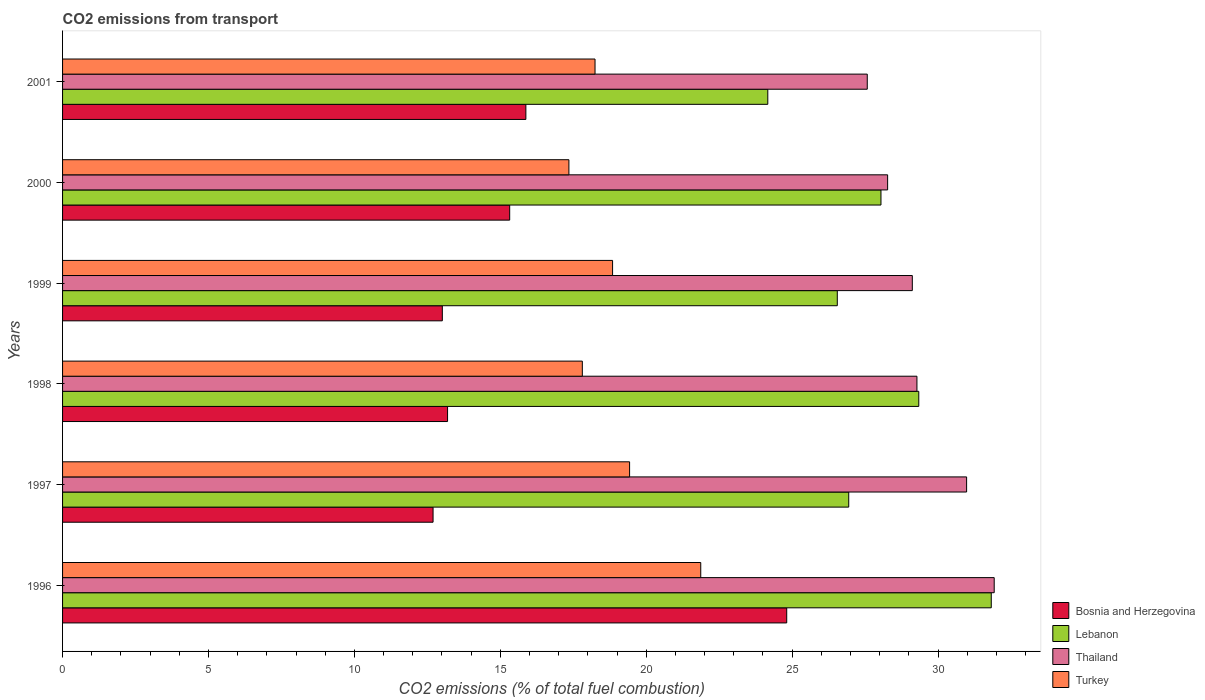How many groups of bars are there?
Keep it short and to the point. 6. Are the number of bars per tick equal to the number of legend labels?
Offer a very short reply. Yes. How many bars are there on the 4th tick from the top?
Ensure brevity in your answer.  4. How many bars are there on the 4th tick from the bottom?
Ensure brevity in your answer.  4. What is the label of the 2nd group of bars from the top?
Your response must be concise. 2000. In how many cases, is the number of bars for a given year not equal to the number of legend labels?
Provide a succinct answer. 0. What is the total CO2 emitted in Thailand in 1997?
Your answer should be very brief. 30.98. Across all years, what is the maximum total CO2 emitted in Lebanon?
Offer a very short reply. 31.82. Across all years, what is the minimum total CO2 emitted in Lebanon?
Your answer should be very brief. 24.17. What is the total total CO2 emitted in Lebanon in the graph?
Offer a very short reply. 166.87. What is the difference between the total CO2 emitted in Bosnia and Herzegovina in 1997 and that in 2000?
Your response must be concise. -2.63. What is the difference between the total CO2 emitted in Thailand in 2000 and the total CO2 emitted in Turkey in 1997?
Give a very brief answer. 8.84. What is the average total CO2 emitted in Turkey per year?
Provide a succinct answer. 18.93. In the year 2001, what is the difference between the total CO2 emitted in Turkey and total CO2 emitted in Bosnia and Herzegovina?
Provide a short and direct response. 2.37. What is the ratio of the total CO2 emitted in Bosnia and Herzegovina in 1996 to that in 1997?
Give a very brief answer. 1.95. Is the total CO2 emitted in Lebanon in 1997 less than that in 1999?
Your answer should be very brief. No. What is the difference between the highest and the second highest total CO2 emitted in Bosnia and Herzegovina?
Offer a terse response. 8.94. What is the difference between the highest and the lowest total CO2 emitted in Turkey?
Make the answer very short. 4.52. What does the 3rd bar from the top in 1998 represents?
Your answer should be very brief. Lebanon. What does the 4th bar from the bottom in 2001 represents?
Your response must be concise. Turkey. Is it the case that in every year, the sum of the total CO2 emitted in Thailand and total CO2 emitted in Turkey is greater than the total CO2 emitted in Lebanon?
Provide a succinct answer. Yes. How many bars are there?
Give a very brief answer. 24. How many years are there in the graph?
Ensure brevity in your answer.  6. Are the values on the major ticks of X-axis written in scientific E-notation?
Ensure brevity in your answer.  No. Does the graph contain any zero values?
Make the answer very short. No. Does the graph contain grids?
Your answer should be very brief. No. Where does the legend appear in the graph?
Offer a very short reply. Bottom right. How are the legend labels stacked?
Keep it short and to the point. Vertical. What is the title of the graph?
Keep it short and to the point. CO2 emissions from transport. Does "Samoa" appear as one of the legend labels in the graph?
Provide a succinct answer. No. What is the label or title of the X-axis?
Provide a succinct answer. CO2 emissions (% of total fuel combustion). What is the label or title of the Y-axis?
Keep it short and to the point. Years. What is the CO2 emissions (% of total fuel combustion) in Bosnia and Herzegovina in 1996?
Keep it short and to the point. 24.82. What is the CO2 emissions (% of total fuel combustion) in Lebanon in 1996?
Give a very brief answer. 31.82. What is the CO2 emissions (% of total fuel combustion) of Thailand in 1996?
Make the answer very short. 31.93. What is the CO2 emissions (% of total fuel combustion) in Turkey in 1996?
Offer a terse response. 21.87. What is the CO2 emissions (% of total fuel combustion) in Bosnia and Herzegovina in 1997?
Give a very brief answer. 12.7. What is the CO2 emissions (% of total fuel combustion) in Lebanon in 1997?
Your answer should be very brief. 26.94. What is the CO2 emissions (% of total fuel combustion) in Thailand in 1997?
Offer a terse response. 30.98. What is the CO2 emissions (% of total fuel combustion) in Turkey in 1997?
Your answer should be very brief. 19.43. What is the CO2 emissions (% of total fuel combustion) in Bosnia and Herzegovina in 1998?
Provide a short and direct response. 13.19. What is the CO2 emissions (% of total fuel combustion) in Lebanon in 1998?
Keep it short and to the point. 29.34. What is the CO2 emissions (% of total fuel combustion) in Thailand in 1998?
Offer a very short reply. 29.28. What is the CO2 emissions (% of total fuel combustion) in Turkey in 1998?
Your answer should be very brief. 17.81. What is the CO2 emissions (% of total fuel combustion) in Bosnia and Herzegovina in 1999?
Keep it short and to the point. 13.01. What is the CO2 emissions (% of total fuel combustion) of Lebanon in 1999?
Give a very brief answer. 26.55. What is the CO2 emissions (% of total fuel combustion) of Thailand in 1999?
Make the answer very short. 29.12. What is the CO2 emissions (% of total fuel combustion) in Turkey in 1999?
Offer a terse response. 18.85. What is the CO2 emissions (% of total fuel combustion) of Bosnia and Herzegovina in 2000?
Your answer should be compact. 15.32. What is the CO2 emissions (% of total fuel combustion) in Lebanon in 2000?
Give a very brief answer. 28.05. What is the CO2 emissions (% of total fuel combustion) in Thailand in 2000?
Make the answer very short. 28.27. What is the CO2 emissions (% of total fuel combustion) in Turkey in 2000?
Your answer should be very brief. 17.35. What is the CO2 emissions (% of total fuel combustion) in Bosnia and Herzegovina in 2001?
Your response must be concise. 15.88. What is the CO2 emissions (% of total fuel combustion) in Lebanon in 2001?
Give a very brief answer. 24.17. What is the CO2 emissions (% of total fuel combustion) in Thailand in 2001?
Provide a short and direct response. 27.58. What is the CO2 emissions (% of total fuel combustion) in Turkey in 2001?
Ensure brevity in your answer.  18.25. Across all years, what is the maximum CO2 emissions (% of total fuel combustion) of Bosnia and Herzegovina?
Your answer should be very brief. 24.82. Across all years, what is the maximum CO2 emissions (% of total fuel combustion) in Lebanon?
Keep it short and to the point. 31.82. Across all years, what is the maximum CO2 emissions (% of total fuel combustion) in Thailand?
Provide a succinct answer. 31.93. Across all years, what is the maximum CO2 emissions (% of total fuel combustion) in Turkey?
Keep it short and to the point. 21.87. Across all years, what is the minimum CO2 emissions (% of total fuel combustion) of Bosnia and Herzegovina?
Offer a very short reply. 12.7. Across all years, what is the minimum CO2 emissions (% of total fuel combustion) in Lebanon?
Provide a succinct answer. 24.17. Across all years, what is the minimum CO2 emissions (% of total fuel combustion) in Thailand?
Provide a short and direct response. 27.58. Across all years, what is the minimum CO2 emissions (% of total fuel combustion) in Turkey?
Offer a terse response. 17.35. What is the total CO2 emissions (% of total fuel combustion) in Bosnia and Herzegovina in the graph?
Ensure brevity in your answer.  94.92. What is the total CO2 emissions (% of total fuel combustion) of Lebanon in the graph?
Make the answer very short. 166.87. What is the total CO2 emissions (% of total fuel combustion) of Thailand in the graph?
Provide a short and direct response. 177.15. What is the total CO2 emissions (% of total fuel combustion) of Turkey in the graph?
Offer a very short reply. 113.56. What is the difference between the CO2 emissions (% of total fuel combustion) of Bosnia and Herzegovina in 1996 and that in 1997?
Offer a very short reply. 12.12. What is the difference between the CO2 emissions (% of total fuel combustion) of Lebanon in 1996 and that in 1997?
Offer a terse response. 4.88. What is the difference between the CO2 emissions (% of total fuel combustion) in Thailand in 1996 and that in 1997?
Provide a succinct answer. 0.95. What is the difference between the CO2 emissions (% of total fuel combustion) of Turkey in 1996 and that in 1997?
Give a very brief answer. 2.44. What is the difference between the CO2 emissions (% of total fuel combustion) of Bosnia and Herzegovina in 1996 and that in 1998?
Give a very brief answer. 11.62. What is the difference between the CO2 emissions (% of total fuel combustion) of Lebanon in 1996 and that in 1998?
Your answer should be very brief. 2.48. What is the difference between the CO2 emissions (% of total fuel combustion) in Thailand in 1996 and that in 1998?
Your response must be concise. 2.65. What is the difference between the CO2 emissions (% of total fuel combustion) in Turkey in 1996 and that in 1998?
Your answer should be compact. 4.06. What is the difference between the CO2 emissions (% of total fuel combustion) of Bosnia and Herzegovina in 1996 and that in 1999?
Give a very brief answer. 11.8. What is the difference between the CO2 emissions (% of total fuel combustion) of Lebanon in 1996 and that in 1999?
Make the answer very short. 5.28. What is the difference between the CO2 emissions (% of total fuel combustion) of Thailand in 1996 and that in 1999?
Keep it short and to the point. 2.81. What is the difference between the CO2 emissions (% of total fuel combustion) in Turkey in 1996 and that in 1999?
Offer a terse response. 3.02. What is the difference between the CO2 emissions (% of total fuel combustion) of Bosnia and Herzegovina in 1996 and that in 2000?
Your answer should be very brief. 9.49. What is the difference between the CO2 emissions (% of total fuel combustion) in Lebanon in 1996 and that in 2000?
Your answer should be compact. 3.78. What is the difference between the CO2 emissions (% of total fuel combustion) in Thailand in 1996 and that in 2000?
Ensure brevity in your answer.  3.65. What is the difference between the CO2 emissions (% of total fuel combustion) of Turkey in 1996 and that in 2000?
Keep it short and to the point. 4.52. What is the difference between the CO2 emissions (% of total fuel combustion) of Bosnia and Herzegovina in 1996 and that in 2001?
Keep it short and to the point. 8.94. What is the difference between the CO2 emissions (% of total fuel combustion) of Lebanon in 1996 and that in 2001?
Offer a very short reply. 7.66. What is the difference between the CO2 emissions (% of total fuel combustion) in Thailand in 1996 and that in 2001?
Your response must be concise. 4.35. What is the difference between the CO2 emissions (% of total fuel combustion) of Turkey in 1996 and that in 2001?
Your answer should be compact. 3.62. What is the difference between the CO2 emissions (% of total fuel combustion) in Bosnia and Herzegovina in 1997 and that in 1998?
Your response must be concise. -0.5. What is the difference between the CO2 emissions (% of total fuel combustion) in Lebanon in 1997 and that in 1998?
Your response must be concise. -2.4. What is the difference between the CO2 emissions (% of total fuel combustion) of Thailand in 1997 and that in 1998?
Your answer should be very brief. 1.7. What is the difference between the CO2 emissions (% of total fuel combustion) of Turkey in 1997 and that in 1998?
Keep it short and to the point. 1.62. What is the difference between the CO2 emissions (% of total fuel combustion) in Bosnia and Herzegovina in 1997 and that in 1999?
Your response must be concise. -0.32. What is the difference between the CO2 emissions (% of total fuel combustion) of Lebanon in 1997 and that in 1999?
Your response must be concise. 0.39. What is the difference between the CO2 emissions (% of total fuel combustion) in Thailand in 1997 and that in 1999?
Make the answer very short. 1.86. What is the difference between the CO2 emissions (% of total fuel combustion) of Turkey in 1997 and that in 1999?
Your answer should be compact. 0.58. What is the difference between the CO2 emissions (% of total fuel combustion) of Bosnia and Herzegovina in 1997 and that in 2000?
Provide a short and direct response. -2.63. What is the difference between the CO2 emissions (% of total fuel combustion) of Lebanon in 1997 and that in 2000?
Ensure brevity in your answer.  -1.1. What is the difference between the CO2 emissions (% of total fuel combustion) in Thailand in 1997 and that in 2000?
Make the answer very short. 2.71. What is the difference between the CO2 emissions (% of total fuel combustion) of Turkey in 1997 and that in 2000?
Your answer should be compact. 2.08. What is the difference between the CO2 emissions (% of total fuel combustion) in Bosnia and Herzegovina in 1997 and that in 2001?
Provide a short and direct response. -3.18. What is the difference between the CO2 emissions (% of total fuel combustion) of Lebanon in 1997 and that in 2001?
Provide a succinct answer. 2.77. What is the difference between the CO2 emissions (% of total fuel combustion) of Thailand in 1997 and that in 2001?
Provide a short and direct response. 3.4. What is the difference between the CO2 emissions (% of total fuel combustion) of Turkey in 1997 and that in 2001?
Keep it short and to the point. 1.18. What is the difference between the CO2 emissions (% of total fuel combustion) of Bosnia and Herzegovina in 1998 and that in 1999?
Ensure brevity in your answer.  0.18. What is the difference between the CO2 emissions (% of total fuel combustion) of Lebanon in 1998 and that in 1999?
Offer a very short reply. 2.79. What is the difference between the CO2 emissions (% of total fuel combustion) of Thailand in 1998 and that in 1999?
Make the answer very short. 0.16. What is the difference between the CO2 emissions (% of total fuel combustion) in Turkey in 1998 and that in 1999?
Make the answer very short. -1.04. What is the difference between the CO2 emissions (% of total fuel combustion) of Bosnia and Herzegovina in 1998 and that in 2000?
Your answer should be very brief. -2.13. What is the difference between the CO2 emissions (% of total fuel combustion) of Lebanon in 1998 and that in 2000?
Your response must be concise. 1.3. What is the difference between the CO2 emissions (% of total fuel combustion) in Turkey in 1998 and that in 2000?
Offer a very short reply. 0.46. What is the difference between the CO2 emissions (% of total fuel combustion) of Bosnia and Herzegovina in 1998 and that in 2001?
Ensure brevity in your answer.  -2.68. What is the difference between the CO2 emissions (% of total fuel combustion) in Lebanon in 1998 and that in 2001?
Offer a very short reply. 5.17. What is the difference between the CO2 emissions (% of total fuel combustion) of Thailand in 1998 and that in 2001?
Offer a terse response. 1.7. What is the difference between the CO2 emissions (% of total fuel combustion) in Turkey in 1998 and that in 2001?
Your answer should be very brief. -0.43. What is the difference between the CO2 emissions (% of total fuel combustion) in Bosnia and Herzegovina in 1999 and that in 2000?
Offer a terse response. -2.31. What is the difference between the CO2 emissions (% of total fuel combustion) in Lebanon in 1999 and that in 2000?
Offer a terse response. -1.5. What is the difference between the CO2 emissions (% of total fuel combustion) in Thailand in 1999 and that in 2000?
Make the answer very short. 0.85. What is the difference between the CO2 emissions (% of total fuel combustion) in Turkey in 1999 and that in 2000?
Your answer should be compact. 1.5. What is the difference between the CO2 emissions (% of total fuel combustion) in Bosnia and Herzegovina in 1999 and that in 2001?
Ensure brevity in your answer.  -2.86. What is the difference between the CO2 emissions (% of total fuel combustion) of Lebanon in 1999 and that in 2001?
Give a very brief answer. 2.38. What is the difference between the CO2 emissions (% of total fuel combustion) in Thailand in 1999 and that in 2001?
Keep it short and to the point. 1.54. What is the difference between the CO2 emissions (% of total fuel combustion) in Turkey in 1999 and that in 2001?
Your response must be concise. 0.6. What is the difference between the CO2 emissions (% of total fuel combustion) in Bosnia and Herzegovina in 2000 and that in 2001?
Your answer should be very brief. -0.55. What is the difference between the CO2 emissions (% of total fuel combustion) in Lebanon in 2000 and that in 2001?
Your answer should be compact. 3.88. What is the difference between the CO2 emissions (% of total fuel combustion) in Thailand in 2000 and that in 2001?
Keep it short and to the point. 0.7. What is the difference between the CO2 emissions (% of total fuel combustion) of Turkey in 2000 and that in 2001?
Offer a terse response. -0.9. What is the difference between the CO2 emissions (% of total fuel combustion) of Bosnia and Herzegovina in 1996 and the CO2 emissions (% of total fuel combustion) of Lebanon in 1997?
Ensure brevity in your answer.  -2.12. What is the difference between the CO2 emissions (% of total fuel combustion) in Bosnia and Herzegovina in 1996 and the CO2 emissions (% of total fuel combustion) in Thailand in 1997?
Offer a very short reply. -6.16. What is the difference between the CO2 emissions (% of total fuel combustion) of Bosnia and Herzegovina in 1996 and the CO2 emissions (% of total fuel combustion) of Turkey in 1997?
Ensure brevity in your answer.  5.38. What is the difference between the CO2 emissions (% of total fuel combustion) of Lebanon in 1996 and the CO2 emissions (% of total fuel combustion) of Thailand in 1997?
Ensure brevity in your answer.  0.84. What is the difference between the CO2 emissions (% of total fuel combustion) of Lebanon in 1996 and the CO2 emissions (% of total fuel combustion) of Turkey in 1997?
Keep it short and to the point. 12.39. What is the difference between the CO2 emissions (% of total fuel combustion) in Thailand in 1996 and the CO2 emissions (% of total fuel combustion) in Turkey in 1997?
Provide a short and direct response. 12.49. What is the difference between the CO2 emissions (% of total fuel combustion) of Bosnia and Herzegovina in 1996 and the CO2 emissions (% of total fuel combustion) of Lebanon in 1998?
Give a very brief answer. -4.53. What is the difference between the CO2 emissions (% of total fuel combustion) of Bosnia and Herzegovina in 1996 and the CO2 emissions (% of total fuel combustion) of Thailand in 1998?
Keep it short and to the point. -4.46. What is the difference between the CO2 emissions (% of total fuel combustion) in Bosnia and Herzegovina in 1996 and the CO2 emissions (% of total fuel combustion) in Turkey in 1998?
Make the answer very short. 7. What is the difference between the CO2 emissions (% of total fuel combustion) in Lebanon in 1996 and the CO2 emissions (% of total fuel combustion) in Thailand in 1998?
Your response must be concise. 2.55. What is the difference between the CO2 emissions (% of total fuel combustion) of Lebanon in 1996 and the CO2 emissions (% of total fuel combustion) of Turkey in 1998?
Make the answer very short. 14.01. What is the difference between the CO2 emissions (% of total fuel combustion) in Thailand in 1996 and the CO2 emissions (% of total fuel combustion) in Turkey in 1998?
Make the answer very short. 14.11. What is the difference between the CO2 emissions (% of total fuel combustion) in Bosnia and Herzegovina in 1996 and the CO2 emissions (% of total fuel combustion) in Lebanon in 1999?
Offer a very short reply. -1.73. What is the difference between the CO2 emissions (% of total fuel combustion) of Bosnia and Herzegovina in 1996 and the CO2 emissions (% of total fuel combustion) of Thailand in 1999?
Ensure brevity in your answer.  -4.3. What is the difference between the CO2 emissions (% of total fuel combustion) in Bosnia and Herzegovina in 1996 and the CO2 emissions (% of total fuel combustion) in Turkey in 1999?
Your answer should be compact. 5.97. What is the difference between the CO2 emissions (% of total fuel combustion) of Lebanon in 1996 and the CO2 emissions (% of total fuel combustion) of Thailand in 1999?
Your answer should be compact. 2.71. What is the difference between the CO2 emissions (% of total fuel combustion) of Lebanon in 1996 and the CO2 emissions (% of total fuel combustion) of Turkey in 1999?
Your answer should be very brief. 12.98. What is the difference between the CO2 emissions (% of total fuel combustion) of Thailand in 1996 and the CO2 emissions (% of total fuel combustion) of Turkey in 1999?
Offer a terse response. 13.08. What is the difference between the CO2 emissions (% of total fuel combustion) in Bosnia and Herzegovina in 1996 and the CO2 emissions (% of total fuel combustion) in Lebanon in 2000?
Your answer should be very brief. -3.23. What is the difference between the CO2 emissions (% of total fuel combustion) of Bosnia and Herzegovina in 1996 and the CO2 emissions (% of total fuel combustion) of Thailand in 2000?
Your answer should be very brief. -3.46. What is the difference between the CO2 emissions (% of total fuel combustion) of Bosnia and Herzegovina in 1996 and the CO2 emissions (% of total fuel combustion) of Turkey in 2000?
Provide a succinct answer. 7.46. What is the difference between the CO2 emissions (% of total fuel combustion) of Lebanon in 1996 and the CO2 emissions (% of total fuel combustion) of Thailand in 2000?
Make the answer very short. 3.55. What is the difference between the CO2 emissions (% of total fuel combustion) of Lebanon in 1996 and the CO2 emissions (% of total fuel combustion) of Turkey in 2000?
Give a very brief answer. 14.47. What is the difference between the CO2 emissions (% of total fuel combustion) in Thailand in 1996 and the CO2 emissions (% of total fuel combustion) in Turkey in 2000?
Make the answer very short. 14.57. What is the difference between the CO2 emissions (% of total fuel combustion) of Bosnia and Herzegovina in 1996 and the CO2 emissions (% of total fuel combustion) of Lebanon in 2001?
Offer a terse response. 0.65. What is the difference between the CO2 emissions (% of total fuel combustion) in Bosnia and Herzegovina in 1996 and the CO2 emissions (% of total fuel combustion) in Thailand in 2001?
Provide a succinct answer. -2.76. What is the difference between the CO2 emissions (% of total fuel combustion) in Bosnia and Herzegovina in 1996 and the CO2 emissions (% of total fuel combustion) in Turkey in 2001?
Offer a terse response. 6.57. What is the difference between the CO2 emissions (% of total fuel combustion) in Lebanon in 1996 and the CO2 emissions (% of total fuel combustion) in Thailand in 2001?
Offer a very short reply. 4.25. What is the difference between the CO2 emissions (% of total fuel combustion) of Lebanon in 1996 and the CO2 emissions (% of total fuel combustion) of Turkey in 2001?
Your answer should be compact. 13.58. What is the difference between the CO2 emissions (% of total fuel combustion) in Thailand in 1996 and the CO2 emissions (% of total fuel combustion) in Turkey in 2001?
Your answer should be very brief. 13.68. What is the difference between the CO2 emissions (% of total fuel combustion) of Bosnia and Herzegovina in 1997 and the CO2 emissions (% of total fuel combustion) of Lebanon in 1998?
Your response must be concise. -16.64. What is the difference between the CO2 emissions (% of total fuel combustion) of Bosnia and Herzegovina in 1997 and the CO2 emissions (% of total fuel combustion) of Thailand in 1998?
Your response must be concise. -16.58. What is the difference between the CO2 emissions (% of total fuel combustion) in Bosnia and Herzegovina in 1997 and the CO2 emissions (% of total fuel combustion) in Turkey in 1998?
Make the answer very short. -5.12. What is the difference between the CO2 emissions (% of total fuel combustion) of Lebanon in 1997 and the CO2 emissions (% of total fuel combustion) of Thailand in 1998?
Give a very brief answer. -2.34. What is the difference between the CO2 emissions (% of total fuel combustion) of Lebanon in 1997 and the CO2 emissions (% of total fuel combustion) of Turkey in 1998?
Offer a very short reply. 9.13. What is the difference between the CO2 emissions (% of total fuel combustion) in Thailand in 1997 and the CO2 emissions (% of total fuel combustion) in Turkey in 1998?
Keep it short and to the point. 13.17. What is the difference between the CO2 emissions (% of total fuel combustion) of Bosnia and Herzegovina in 1997 and the CO2 emissions (% of total fuel combustion) of Lebanon in 1999?
Offer a terse response. -13.85. What is the difference between the CO2 emissions (% of total fuel combustion) of Bosnia and Herzegovina in 1997 and the CO2 emissions (% of total fuel combustion) of Thailand in 1999?
Offer a very short reply. -16.42. What is the difference between the CO2 emissions (% of total fuel combustion) in Bosnia and Herzegovina in 1997 and the CO2 emissions (% of total fuel combustion) in Turkey in 1999?
Your response must be concise. -6.15. What is the difference between the CO2 emissions (% of total fuel combustion) in Lebanon in 1997 and the CO2 emissions (% of total fuel combustion) in Thailand in 1999?
Your answer should be compact. -2.18. What is the difference between the CO2 emissions (% of total fuel combustion) of Lebanon in 1997 and the CO2 emissions (% of total fuel combustion) of Turkey in 1999?
Give a very brief answer. 8.09. What is the difference between the CO2 emissions (% of total fuel combustion) in Thailand in 1997 and the CO2 emissions (% of total fuel combustion) in Turkey in 1999?
Ensure brevity in your answer.  12.13. What is the difference between the CO2 emissions (% of total fuel combustion) of Bosnia and Herzegovina in 1997 and the CO2 emissions (% of total fuel combustion) of Lebanon in 2000?
Offer a terse response. -15.35. What is the difference between the CO2 emissions (% of total fuel combustion) in Bosnia and Herzegovina in 1997 and the CO2 emissions (% of total fuel combustion) in Thailand in 2000?
Keep it short and to the point. -15.58. What is the difference between the CO2 emissions (% of total fuel combustion) of Bosnia and Herzegovina in 1997 and the CO2 emissions (% of total fuel combustion) of Turkey in 2000?
Offer a terse response. -4.65. What is the difference between the CO2 emissions (% of total fuel combustion) of Lebanon in 1997 and the CO2 emissions (% of total fuel combustion) of Thailand in 2000?
Your answer should be very brief. -1.33. What is the difference between the CO2 emissions (% of total fuel combustion) of Lebanon in 1997 and the CO2 emissions (% of total fuel combustion) of Turkey in 2000?
Make the answer very short. 9.59. What is the difference between the CO2 emissions (% of total fuel combustion) of Thailand in 1997 and the CO2 emissions (% of total fuel combustion) of Turkey in 2000?
Offer a terse response. 13.63. What is the difference between the CO2 emissions (% of total fuel combustion) in Bosnia and Herzegovina in 1997 and the CO2 emissions (% of total fuel combustion) in Lebanon in 2001?
Your response must be concise. -11.47. What is the difference between the CO2 emissions (% of total fuel combustion) in Bosnia and Herzegovina in 1997 and the CO2 emissions (% of total fuel combustion) in Thailand in 2001?
Your answer should be compact. -14.88. What is the difference between the CO2 emissions (% of total fuel combustion) of Bosnia and Herzegovina in 1997 and the CO2 emissions (% of total fuel combustion) of Turkey in 2001?
Your answer should be compact. -5.55. What is the difference between the CO2 emissions (% of total fuel combustion) in Lebanon in 1997 and the CO2 emissions (% of total fuel combustion) in Thailand in 2001?
Provide a short and direct response. -0.64. What is the difference between the CO2 emissions (% of total fuel combustion) in Lebanon in 1997 and the CO2 emissions (% of total fuel combustion) in Turkey in 2001?
Your answer should be compact. 8.69. What is the difference between the CO2 emissions (% of total fuel combustion) of Thailand in 1997 and the CO2 emissions (% of total fuel combustion) of Turkey in 2001?
Provide a succinct answer. 12.73. What is the difference between the CO2 emissions (% of total fuel combustion) in Bosnia and Herzegovina in 1998 and the CO2 emissions (% of total fuel combustion) in Lebanon in 1999?
Your response must be concise. -13.36. What is the difference between the CO2 emissions (% of total fuel combustion) in Bosnia and Herzegovina in 1998 and the CO2 emissions (% of total fuel combustion) in Thailand in 1999?
Your answer should be compact. -15.93. What is the difference between the CO2 emissions (% of total fuel combustion) of Bosnia and Herzegovina in 1998 and the CO2 emissions (% of total fuel combustion) of Turkey in 1999?
Give a very brief answer. -5.65. What is the difference between the CO2 emissions (% of total fuel combustion) of Lebanon in 1998 and the CO2 emissions (% of total fuel combustion) of Thailand in 1999?
Your response must be concise. 0.22. What is the difference between the CO2 emissions (% of total fuel combustion) in Lebanon in 1998 and the CO2 emissions (% of total fuel combustion) in Turkey in 1999?
Offer a terse response. 10.49. What is the difference between the CO2 emissions (% of total fuel combustion) in Thailand in 1998 and the CO2 emissions (% of total fuel combustion) in Turkey in 1999?
Offer a very short reply. 10.43. What is the difference between the CO2 emissions (% of total fuel combustion) of Bosnia and Herzegovina in 1998 and the CO2 emissions (% of total fuel combustion) of Lebanon in 2000?
Offer a very short reply. -14.85. What is the difference between the CO2 emissions (% of total fuel combustion) in Bosnia and Herzegovina in 1998 and the CO2 emissions (% of total fuel combustion) in Thailand in 2000?
Your answer should be very brief. -15.08. What is the difference between the CO2 emissions (% of total fuel combustion) of Bosnia and Herzegovina in 1998 and the CO2 emissions (% of total fuel combustion) of Turkey in 2000?
Your answer should be compact. -4.16. What is the difference between the CO2 emissions (% of total fuel combustion) in Lebanon in 1998 and the CO2 emissions (% of total fuel combustion) in Thailand in 2000?
Your answer should be compact. 1.07. What is the difference between the CO2 emissions (% of total fuel combustion) in Lebanon in 1998 and the CO2 emissions (% of total fuel combustion) in Turkey in 2000?
Your response must be concise. 11.99. What is the difference between the CO2 emissions (% of total fuel combustion) of Thailand in 1998 and the CO2 emissions (% of total fuel combustion) of Turkey in 2000?
Offer a terse response. 11.93. What is the difference between the CO2 emissions (% of total fuel combustion) in Bosnia and Herzegovina in 1998 and the CO2 emissions (% of total fuel combustion) in Lebanon in 2001?
Provide a short and direct response. -10.97. What is the difference between the CO2 emissions (% of total fuel combustion) of Bosnia and Herzegovina in 1998 and the CO2 emissions (% of total fuel combustion) of Thailand in 2001?
Provide a short and direct response. -14.38. What is the difference between the CO2 emissions (% of total fuel combustion) in Bosnia and Herzegovina in 1998 and the CO2 emissions (% of total fuel combustion) in Turkey in 2001?
Make the answer very short. -5.05. What is the difference between the CO2 emissions (% of total fuel combustion) in Lebanon in 1998 and the CO2 emissions (% of total fuel combustion) in Thailand in 2001?
Keep it short and to the point. 1.77. What is the difference between the CO2 emissions (% of total fuel combustion) of Lebanon in 1998 and the CO2 emissions (% of total fuel combustion) of Turkey in 2001?
Offer a terse response. 11.09. What is the difference between the CO2 emissions (% of total fuel combustion) in Thailand in 1998 and the CO2 emissions (% of total fuel combustion) in Turkey in 2001?
Offer a terse response. 11.03. What is the difference between the CO2 emissions (% of total fuel combustion) of Bosnia and Herzegovina in 1999 and the CO2 emissions (% of total fuel combustion) of Lebanon in 2000?
Make the answer very short. -15.03. What is the difference between the CO2 emissions (% of total fuel combustion) of Bosnia and Herzegovina in 1999 and the CO2 emissions (% of total fuel combustion) of Thailand in 2000?
Keep it short and to the point. -15.26. What is the difference between the CO2 emissions (% of total fuel combustion) of Bosnia and Herzegovina in 1999 and the CO2 emissions (% of total fuel combustion) of Turkey in 2000?
Offer a terse response. -4.34. What is the difference between the CO2 emissions (% of total fuel combustion) in Lebanon in 1999 and the CO2 emissions (% of total fuel combustion) in Thailand in 2000?
Make the answer very short. -1.72. What is the difference between the CO2 emissions (% of total fuel combustion) in Lebanon in 1999 and the CO2 emissions (% of total fuel combustion) in Turkey in 2000?
Ensure brevity in your answer.  9.2. What is the difference between the CO2 emissions (% of total fuel combustion) in Thailand in 1999 and the CO2 emissions (% of total fuel combustion) in Turkey in 2000?
Your response must be concise. 11.77. What is the difference between the CO2 emissions (% of total fuel combustion) of Bosnia and Herzegovina in 1999 and the CO2 emissions (% of total fuel combustion) of Lebanon in 2001?
Ensure brevity in your answer.  -11.15. What is the difference between the CO2 emissions (% of total fuel combustion) of Bosnia and Herzegovina in 1999 and the CO2 emissions (% of total fuel combustion) of Thailand in 2001?
Give a very brief answer. -14.56. What is the difference between the CO2 emissions (% of total fuel combustion) in Bosnia and Herzegovina in 1999 and the CO2 emissions (% of total fuel combustion) in Turkey in 2001?
Keep it short and to the point. -5.23. What is the difference between the CO2 emissions (% of total fuel combustion) of Lebanon in 1999 and the CO2 emissions (% of total fuel combustion) of Thailand in 2001?
Your answer should be compact. -1.03. What is the difference between the CO2 emissions (% of total fuel combustion) in Lebanon in 1999 and the CO2 emissions (% of total fuel combustion) in Turkey in 2001?
Make the answer very short. 8.3. What is the difference between the CO2 emissions (% of total fuel combustion) in Thailand in 1999 and the CO2 emissions (% of total fuel combustion) in Turkey in 2001?
Your answer should be very brief. 10.87. What is the difference between the CO2 emissions (% of total fuel combustion) in Bosnia and Herzegovina in 2000 and the CO2 emissions (% of total fuel combustion) in Lebanon in 2001?
Keep it short and to the point. -8.85. What is the difference between the CO2 emissions (% of total fuel combustion) of Bosnia and Herzegovina in 2000 and the CO2 emissions (% of total fuel combustion) of Thailand in 2001?
Keep it short and to the point. -12.25. What is the difference between the CO2 emissions (% of total fuel combustion) of Bosnia and Herzegovina in 2000 and the CO2 emissions (% of total fuel combustion) of Turkey in 2001?
Offer a terse response. -2.92. What is the difference between the CO2 emissions (% of total fuel combustion) in Lebanon in 2000 and the CO2 emissions (% of total fuel combustion) in Thailand in 2001?
Provide a short and direct response. 0.47. What is the difference between the CO2 emissions (% of total fuel combustion) in Lebanon in 2000 and the CO2 emissions (% of total fuel combustion) in Turkey in 2001?
Offer a very short reply. 9.8. What is the difference between the CO2 emissions (% of total fuel combustion) of Thailand in 2000 and the CO2 emissions (% of total fuel combustion) of Turkey in 2001?
Offer a terse response. 10.03. What is the average CO2 emissions (% of total fuel combustion) in Bosnia and Herzegovina per year?
Your answer should be compact. 15.82. What is the average CO2 emissions (% of total fuel combustion) in Lebanon per year?
Offer a terse response. 27.81. What is the average CO2 emissions (% of total fuel combustion) of Thailand per year?
Offer a terse response. 29.53. What is the average CO2 emissions (% of total fuel combustion) in Turkey per year?
Ensure brevity in your answer.  18.93. In the year 1996, what is the difference between the CO2 emissions (% of total fuel combustion) of Bosnia and Herzegovina and CO2 emissions (% of total fuel combustion) of Lebanon?
Offer a terse response. -7.01. In the year 1996, what is the difference between the CO2 emissions (% of total fuel combustion) in Bosnia and Herzegovina and CO2 emissions (% of total fuel combustion) in Thailand?
Your response must be concise. -7.11. In the year 1996, what is the difference between the CO2 emissions (% of total fuel combustion) in Bosnia and Herzegovina and CO2 emissions (% of total fuel combustion) in Turkey?
Provide a short and direct response. 2.95. In the year 1996, what is the difference between the CO2 emissions (% of total fuel combustion) of Lebanon and CO2 emissions (% of total fuel combustion) of Thailand?
Ensure brevity in your answer.  -0.1. In the year 1996, what is the difference between the CO2 emissions (% of total fuel combustion) in Lebanon and CO2 emissions (% of total fuel combustion) in Turkey?
Provide a short and direct response. 9.96. In the year 1996, what is the difference between the CO2 emissions (% of total fuel combustion) in Thailand and CO2 emissions (% of total fuel combustion) in Turkey?
Keep it short and to the point. 10.06. In the year 1997, what is the difference between the CO2 emissions (% of total fuel combustion) of Bosnia and Herzegovina and CO2 emissions (% of total fuel combustion) of Lebanon?
Provide a succinct answer. -14.24. In the year 1997, what is the difference between the CO2 emissions (% of total fuel combustion) of Bosnia and Herzegovina and CO2 emissions (% of total fuel combustion) of Thailand?
Provide a short and direct response. -18.28. In the year 1997, what is the difference between the CO2 emissions (% of total fuel combustion) in Bosnia and Herzegovina and CO2 emissions (% of total fuel combustion) in Turkey?
Provide a succinct answer. -6.73. In the year 1997, what is the difference between the CO2 emissions (% of total fuel combustion) of Lebanon and CO2 emissions (% of total fuel combustion) of Thailand?
Your answer should be compact. -4.04. In the year 1997, what is the difference between the CO2 emissions (% of total fuel combustion) in Lebanon and CO2 emissions (% of total fuel combustion) in Turkey?
Your answer should be compact. 7.51. In the year 1997, what is the difference between the CO2 emissions (% of total fuel combustion) in Thailand and CO2 emissions (% of total fuel combustion) in Turkey?
Offer a terse response. 11.55. In the year 1998, what is the difference between the CO2 emissions (% of total fuel combustion) of Bosnia and Herzegovina and CO2 emissions (% of total fuel combustion) of Lebanon?
Provide a short and direct response. -16.15. In the year 1998, what is the difference between the CO2 emissions (% of total fuel combustion) of Bosnia and Herzegovina and CO2 emissions (% of total fuel combustion) of Thailand?
Provide a succinct answer. -16.08. In the year 1998, what is the difference between the CO2 emissions (% of total fuel combustion) in Bosnia and Herzegovina and CO2 emissions (% of total fuel combustion) in Turkey?
Offer a very short reply. -4.62. In the year 1998, what is the difference between the CO2 emissions (% of total fuel combustion) of Lebanon and CO2 emissions (% of total fuel combustion) of Thailand?
Keep it short and to the point. 0.06. In the year 1998, what is the difference between the CO2 emissions (% of total fuel combustion) in Lebanon and CO2 emissions (% of total fuel combustion) in Turkey?
Provide a short and direct response. 11.53. In the year 1998, what is the difference between the CO2 emissions (% of total fuel combustion) of Thailand and CO2 emissions (% of total fuel combustion) of Turkey?
Your answer should be very brief. 11.47. In the year 1999, what is the difference between the CO2 emissions (% of total fuel combustion) of Bosnia and Herzegovina and CO2 emissions (% of total fuel combustion) of Lebanon?
Your response must be concise. -13.54. In the year 1999, what is the difference between the CO2 emissions (% of total fuel combustion) of Bosnia and Herzegovina and CO2 emissions (% of total fuel combustion) of Thailand?
Your answer should be compact. -16.11. In the year 1999, what is the difference between the CO2 emissions (% of total fuel combustion) of Bosnia and Herzegovina and CO2 emissions (% of total fuel combustion) of Turkey?
Offer a terse response. -5.83. In the year 1999, what is the difference between the CO2 emissions (% of total fuel combustion) of Lebanon and CO2 emissions (% of total fuel combustion) of Thailand?
Provide a short and direct response. -2.57. In the year 1999, what is the difference between the CO2 emissions (% of total fuel combustion) of Lebanon and CO2 emissions (% of total fuel combustion) of Turkey?
Ensure brevity in your answer.  7.7. In the year 1999, what is the difference between the CO2 emissions (% of total fuel combustion) of Thailand and CO2 emissions (% of total fuel combustion) of Turkey?
Ensure brevity in your answer.  10.27. In the year 2000, what is the difference between the CO2 emissions (% of total fuel combustion) in Bosnia and Herzegovina and CO2 emissions (% of total fuel combustion) in Lebanon?
Your response must be concise. -12.72. In the year 2000, what is the difference between the CO2 emissions (% of total fuel combustion) in Bosnia and Herzegovina and CO2 emissions (% of total fuel combustion) in Thailand?
Give a very brief answer. -12.95. In the year 2000, what is the difference between the CO2 emissions (% of total fuel combustion) of Bosnia and Herzegovina and CO2 emissions (% of total fuel combustion) of Turkey?
Your response must be concise. -2.03. In the year 2000, what is the difference between the CO2 emissions (% of total fuel combustion) in Lebanon and CO2 emissions (% of total fuel combustion) in Thailand?
Give a very brief answer. -0.23. In the year 2000, what is the difference between the CO2 emissions (% of total fuel combustion) of Lebanon and CO2 emissions (% of total fuel combustion) of Turkey?
Your answer should be compact. 10.69. In the year 2000, what is the difference between the CO2 emissions (% of total fuel combustion) in Thailand and CO2 emissions (% of total fuel combustion) in Turkey?
Offer a terse response. 10.92. In the year 2001, what is the difference between the CO2 emissions (% of total fuel combustion) in Bosnia and Herzegovina and CO2 emissions (% of total fuel combustion) in Lebanon?
Make the answer very short. -8.29. In the year 2001, what is the difference between the CO2 emissions (% of total fuel combustion) of Bosnia and Herzegovina and CO2 emissions (% of total fuel combustion) of Thailand?
Provide a short and direct response. -11.7. In the year 2001, what is the difference between the CO2 emissions (% of total fuel combustion) of Bosnia and Herzegovina and CO2 emissions (% of total fuel combustion) of Turkey?
Provide a short and direct response. -2.37. In the year 2001, what is the difference between the CO2 emissions (% of total fuel combustion) of Lebanon and CO2 emissions (% of total fuel combustion) of Thailand?
Ensure brevity in your answer.  -3.41. In the year 2001, what is the difference between the CO2 emissions (% of total fuel combustion) of Lebanon and CO2 emissions (% of total fuel combustion) of Turkey?
Offer a terse response. 5.92. In the year 2001, what is the difference between the CO2 emissions (% of total fuel combustion) in Thailand and CO2 emissions (% of total fuel combustion) in Turkey?
Offer a terse response. 9.33. What is the ratio of the CO2 emissions (% of total fuel combustion) of Bosnia and Herzegovina in 1996 to that in 1997?
Provide a succinct answer. 1.95. What is the ratio of the CO2 emissions (% of total fuel combustion) of Lebanon in 1996 to that in 1997?
Offer a very short reply. 1.18. What is the ratio of the CO2 emissions (% of total fuel combustion) of Thailand in 1996 to that in 1997?
Your answer should be compact. 1.03. What is the ratio of the CO2 emissions (% of total fuel combustion) in Turkey in 1996 to that in 1997?
Offer a terse response. 1.13. What is the ratio of the CO2 emissions (% of total fuel combustion) of Bosnia and Herzegovina in 1996 to that in 1998?
Offer a very short reply. 1.88. What is the ratio of the CO2 emissions (% of total fuel combustion) in Lebanon in 1996 to that in 1998?
Give a very brief answer. 1.08. What is the ratio of the CO2 emissions (% of total fuel combustion) of Thailand in 1996 to that in 1998?
Provide a short and direct response. 1.09. What is the ratio of the CO2 emissions (% of total fuel combustion) of Turkey in 1996 to that in 1998?
Provide a succinct answer. 1.23. What is the ratio of the CO2 emissions (% of total fuel combustion) of Bosnia and Herzegovina in 1996 to that in 1999?
Provide a short and direct response. 1.91. What is the ratio of the CO2 emissions (% of total fuel combustion) in Lebanon in 1996 to that in 1999?
Your answer should be very brief. 1.2. What is the ratio of the CO2 emissions (% of total fuel combustion) of Thailand in 1996 to that in 1999?
Provide a succinct answer. 1.1. What is the ratio of the CO2 emissions (% of total fuel combustion) in Turkey in 1996 to that in 1999?
Keep it short and to the point. 1.16. What is the ratio of the CO2 emissions (% of total fuel combustion) in Bosnia and Herzegovina in 1996 to that in 2000?
Provide a succinct answer. 1.62. What is the ratio of the CO2 emissions (% of total fuel combustion) in Lebanon in 1996 to that in 2000?
Offer a terse response. 1.13. What is the ratio of the CO2 emissions (% of total fuel combustion) of Thailand in 1996 to that in 2000?
Your answer should be very brief. 1.13. What is the ratio of the CO2 emissions (% of total fuel combustion) of Turkey in 1996 to that in 2000?
Give a very brief answer. 1.26. What is the ratio of the CO2 emissions (% of total fuel combustion) in Bosnia and Herzegovina in 1996 to that in 2001?
Make the answer very short. 1.56. What is the ratio of the CO2 emissions (% of total fuel combustion) of Lebanon in 1996 to that in 2001?
Offer a terse response. 1.32. What is the ratio of the CO2 emissions (% of total fuel combustion) in Thailand in 1996 to that in 2001?
Offer a very short reply. 1.16. What is the ratio of the CO2 emissions (% of total fuel combustion) of Turkey in 1996 to that in 2001?
Make the answer very short. 1.2. What is the ratio of the CO2 emissions (% of total fuel combustion) in Bosnia and Herzegovina in 1997 to that in 1998?
Your response must be concise. 0.96. What is the ratio of the CO2 emissions (% of total fuel combustion) of Lebanon in 1997 to that in 1998?
Offer a terse response. 0.92. What is the ratio of the CO2 emissions (% of total fuel combustion) of Thailand in 1997 to that in 1998?
Make the answer very short. 1.06. What is the ratio of the CO2 emissions (% of total fuel combustion) in Bosnia and Herzegovina in 1997 to that in 1999?
Offer a very short reply. 0.98. What is the ratio of the CO2 emissions (% of total fuel combustion) of Lebanon in 1997 to that in 1999?
Your response must be concise. 1.01. What is the ratio of the CO2 emissions (% of total fuel combustion) in Thailand in 1997 to that in 1999?
Provide a short and direct response. 1.06. What is the ratio of the CO2 emissions (% of total fuel combustion) of Turkey in 1997 to that in 1999?
Provide a short and direct response. 1.03. What is the ratio of the CO2 emissions (% of total fuel combustion) in Bosnia and Herzegovina in 1997 to that in 2000?
Offer a very short reply. 0.83. What is the ratio of the CO2 emissions (% of total fuel combustion) of Lebanon in 1997 to that in 2000?
Your response must be concise. 0.96. What is the ratio of the CO2 emissions (% of total fuel combustion) in Thailand in 1997 to that in 2000?
Offer a very short reply. 1.1. What is the ratio of the CO2 emissions (% of total fuel combustion) in Turkey in 1997 to that in 2000?
Keep it short and to the point. 1.12. What is the ratio of the CO2 emissions (% of total fuel combustion) in Bosnia and Herzegovina in 1997 to that in 2001?
Offer a terse response. 0.8. What is the ratio of the CO2 emissions (% of total fuel combustion) of Lebanon in 1997 to that in 2001?
Provide a short and direct response. 1.11. What is the ratio of the CO2 emissions (% of total fuel combustion) in Thailand in 1997 to that in 2001?
Your answer should be very brief. 1.12. What is the ratio of the CO2 emissions (% of total fuel combustion) of Turkey in 1997 to that in 2001?
Give a very brief answer. 1.06. What is the ratio of the CO2 emissions (% of total fuel combustion) of Bosnia and Herzegovina in 1998 to that in 1999?
Provide a succinct answer. 1.01. What is the ratio of the CO2 emissions (% of total fuel combustion) in Lebanon in 1998 to that in 1999?
Provide a short and direct response. 1.11. What is the ratio of the CO2 emissions (% of total fuel combustion) in Thailand in 1998 to that in 1999?
Make the answer very short. 1.01. What is the ratio of the CO2 emissions (% of total fuel combustion) of Turkey in 1998 to that in 1999?
Offer a terse response. 0.94. What is the ratio of the CO2 emissions (% of total fuel combustion) in Bosnia and Herzegovina in 1998 to that in 2000?
Keep it short and to the point. 0.86. What is the ratio of the CO2 emissions (% of total fuel combustion) of Lebanon in 1998 to that in 2000?
Your response must be concise. 1.05. What is the ratio of the CO2 emissions (% of total fuel combustion) of Thailand in 1998 to that in 2000?
Your answer should be compact. 1.04. What is the ratio of the CO2 emissions (% of total fuel combustion) in Turkey in 1998 to that in 2000?
Give a very brief answer. 1.03. What is the ratio of the CO2 emissions (% of total fuel combustion) of Bosnia and Herzegovina in 1998 to that in 2001?
Offer a very short reply. 0.83. What is the ratio of the CO2 emissions (% of total fuel combustion) in Lebanon in 1998 to that in 2001?
Provide a succinct answer. 1.21. What is the ratio of the CO2 emissions (% of total fuel combustion) of Thailand in 1998 to that in 2001?
Your response must be concise. 1.06. What is the ratio of the CO2 emissions (% of total fuel combustion) in Turkey in 1998 to that in 2001?
Your answer should be compact. 0.98. What is the ratio of the CO2 emissions (% of total fuel combustion) of Bosnia and Herzegovina in 1999 to that in 2000?
Your answer should be very brief. 0.85. What is the ratio of the CO2 emissions (% of total fuel combustion) in Lebanon in 1999 to that in 2000?
Make the answer very short. 0.95. What is the ratio of the CO2 emissions (% of total fuel combustion) in Thailand in 1999 to that in 2000?
Your answer should be very brief. 1.03. What is the ratio of the CO2 emissions (% of total fuel combustion) of Turkey in 1999 to that in 2000?
Your response must be concise. 1.09. What is the ratio of the CO2 emissions (% of total fuel combustion) in Bosnia and Herzegovina in 1999 to that in 2001?
Provide a short and direct response. 0.82. What is the ratio of the CO2 emissions (% of total fuel combustion) of Lebanon in 1999 to that in 2001?
Offer a very short reply. 1.1. What is the ratio of the CO2 emissions (% of total fuel combustion) of Thailand in 1999 to that in 2001?
Your answer should be very brief. 1.06. What is the ratio of the CO2 emissions (% of total fuel combustion) in Turkey in 1999 to that in 2001?
Make the answer very short. 1.03. What is the ratio of the CO2 emissions (% of total fuel combustion) in Bosnia and Herzegovina in 2000 to that in 2001?
Your answer should be compact. 0.97. What is the ratio of the CO2 emissions (% of total fuel combustion) in Lebanon in 2000 to that in 2001?
Your answer should be compact. 1.16. What is the ratio of the CO2 emissions (% of total fuel combustion) of Thailand in 2000 to that in 2001?
Your response must be concise. 1.03. What is the ratio of the CO2 emissions (% of total fuel combustion) of Turkey in 2000 to that in 2001?
Provide a short and direct response. 0.95. What is the difference between the highest and the second highest CO2 emissions (% of total fuel combustion) in Bosnia and Herzegovina?
Offer a very short reply. 8.94. What is the difference between the highest and the second highest CO2 emissions (% of total fuel combustion) of Lebanon?
Your answer should be very brief. 2.48. What is the difference between the highest and the second highest CO2 emissions (% of total fuel combustion) in Thailand?
Offer a very short reply. 0.95. What is the difference between the highest and the second highest CO2 emissions (% of total fuel combustion) of Turkey?
Offer a very short reply. 2.44. What is the difference between the highest and the lowest CO2 emissions (% of total fuel combustion) of Bosnia and Herzegovina?
Offer a very short reply. 12.12. What is the difference between the highest and the lowest CO2 emissions (% of total fuel combustion) in Lebanon?
Keep it short and to the point. 7.66. What is the difference between the highest and the lowest CO2 emissions (% of total fuel combustion) in Thailand?
Provide a short and direct response. 4.35. What is the difference between the highest and the lowest CO2 emissions (% of total fuel combustion) of Turkey?
Give a very brief answer. 4.52. 